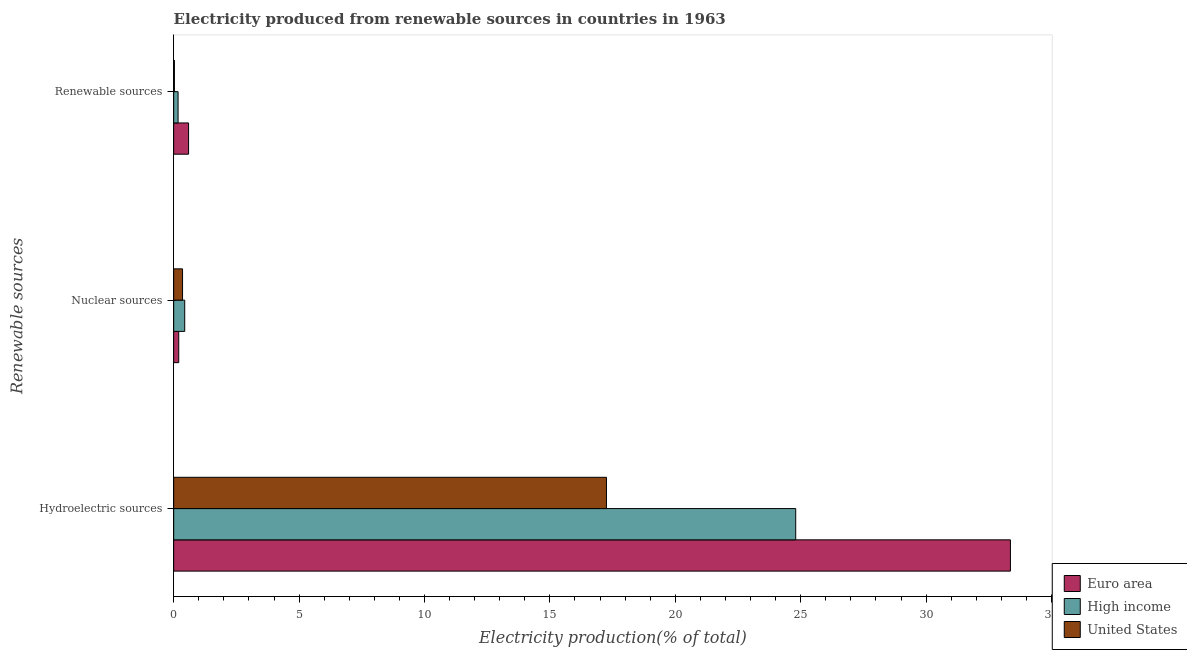Are the number of bars per tick equal to the number of legend labels?
Give a very brief answer. Yes. How many bars are there on the 3rd tick from the top?
Ensure brevity in your answer.  3. How many bars are there on the 2nd tick from the bottom?
Ensure brevity in your answer.  3. What is the label of the 2nd group of bars from the top?
Give a very brief answer. Nuclear sources. What is the percentage of electricity produced by hydroelectric sources in High income?
Keep it short and to the point. 24.8. Across all countries, what is the maximum percentage of electricity produced by renewable sources?
Your answer should be compact. 0.59. Across all countries, what is the minimum percentage of electricity produced by hydroelectric sources?
Ensure brevity in your answer.  17.26. In which country was the percentage of electricity produced by renewable sources maximum?
Keep it short and to the point. Euro area. What is the total percentage of electricity produced by renewable sources in the graph?
Offer a very short reply. 0.8. What is the difference between the percentage of electricity produced by renewable sources in Euro area and that in High income?
Give a very brief answer. 0.42. What is the difference between the percentage of electricity produced by nuclear sources in High income and the percentage of electricity produced by hydroelectric sources in United States?
Give a very brief answer. -16.81. What is the average percentage of electricity produced by hydroelectric sources per country?
Offer a very short reply. 25.14. What is the difference between the percentage of electricity produced by nuclear sources and percentage of electricity produced by hydroelectric sources in High income?
Your response must be concise. -24.36. In how many countries, is the percentage of electricity produced by hydroelectric sources greater than 29 %?
Your answer should be compact. 1. What is the ratio of the percentage of electricity produced by nuclear sources in High income to that in Euro area?
Your answer should be very brief. 2.18. Is the percentage of electricity produced by nuclear sources in United States less than that in Euro area?
Your answer should be very brief. No. Is the difference between the percentage of electricity produced by renewable sources in United States and Euro area greater than the difference between the percentage of electricity produced by hydroelectric sources in United States and Euro area?
Keep it short and to the point. Yes. What is the difference between the highest and the second highest percentage of electricity produced by hydroelectric sources?
Give a very brief answer. 8.56. What is the difference between the highest and the lowest percentage of electricity produced by hydroelectric sources?
Provide a succinct answer. 16.11. In how many countries, is the percentage of electricity produced by renewable sources greater than the average percentage of electricity produced by renewable sources taken over all countries?
Your answer should be very brief. 1. Is the sum of the percentage of electricity produced by hydroelectric sources in United States and Euro area greater than the maximum percentage of electricity produced by nuclear sources across all countries?
Your answer should be compact. Yes. Is it the case that in every country, the sum of the percentage of electricity produced by hydroelectric sources and percentage of electricity produced by nuclear sources is greater than the percentage of electricity produced by renewable sources?
Provide a short and direct response. Yes. How many bars are there?
Offer a very short reply. 9. How many countries are there in the graph?
Give a very brief answer. 3. Are the values on the major ticks of X-axis written in scientific E-notation?
Give a very brief answer. No. Does the graph contain any zero values?
Offer a terse response. No. Does the graph contain grids?
Offer a very short reply. No. How many legend labels are there?
Give a very brief answer. 3. What is the title of the graph?
Your answer should be very brief. Electricity produced from renewable sources in countries in 1963. What is the label or title of the Y-axis?
Offer a terse response. Renewable sources. What is the Electricity production(% of total) in Euro area in Hydroelectric sources?
Keep it short and to the point. 33.36. What is the Electricity production(% of total) of High income in Hydroelectric sources?
Give a very brief answer. 24.8. What is the Electricity production(% of total) in United States in Hydroelectric sources?
Ensure brevity in your answer.  17.26. What is the Electricity production(% of total) of Euro area in Nuclear sources?
Your response must be concise. 0.2. What is the Electricity production(% of total) in High income in Nuclear sources?
Provide a succinct answer. 0.44. What is the Electricity production(% of total) of United States in Nuclear sources?
Give a very brief answer. 0.35. What is the Electricity production(% of total) of Euro area in Renewable sources?
Your response must be concise. 0.59. What is the Electricity production(% of total) of High income in Renewable sources?
Give a very brief answer. 0.18. What is the Electricity production(% of total) in United States in Renewable sources?
Provide a short and direct response. 0.03. Across all Renewable sources, what is the maximum Electricity production(% of total) in Euro area?
Provide a succinct answer. 33.36. Across all Renewable sources, what is the maximum Electricity production(% of total) of High income?
Make the answer very short. 24.8. Across all Renewable sources, what is the maximum Electricity production(% of total) in United States?
Your answer should be very brief. 17.26. Across all Renewable sources, what is the minimum Electricity production(% of total) in Euro area?
Your answer should be compact. 0.2. Across all Renewable sources, what is the minimum Electricity production(% of total) in High income?
Your answer should be very brief. 0.18. Across all Renewable sources, what is the minimum Electricity production(% of total) of United States?
Offer a very short reply. 0.03. What is the total Electricity production(% of total) of Euro area in the graph?
Your answer should be very brief. 34.16. What is the total Electricity production(% of total) of High income in the graph?
Provide a short and direct response. 25.42. What is the total Electricity production(% of total) of United States in the graph?
Offer a terse response. 17.64. What is the difference between the Electricity production(% of total) of Euro area in Hydroelectric sources and that in Nuclear sources?
Offer a very short reply. 33.16. What is the difference between the Electricity production(% of total) in High income in Hydroelectric sources and that in Nuclear sources?
Keep it short and to the point. 24.36. What is the difference between the Electricity production(% of total) of United States in Hydroelectric sources and that in Nuclear sources?
Provide a short and direct response. 16.9. What is the difference between the Electricity production(% of total) in Euro area in Hydroelectric sources and that in Renewable sources?
Provide a succinct answer. 32.77. What is the difference between the Electricity production(% of total) of High income in Hydroelectric sources and that in Renewable sources?
Give a very brief answer. 24.63. What is the difference between the Electricity production(% of total) in United States in Hydroelectric sources and that in Renewable sources?
Keep it short and to the point. 17.23. What is the difference between the Electricity production(% of total) of Euro area in Nuclear sources and that in Renewable sources?
Offer a terse response. -0.39. What is the difference between the Electricity production(% of total) of High income in Nuclear sources and that in Renewable sources?
Offer a terse response. 0.27. What is the difference between the Electricity production(% of total) of United States in Nuclear sources and that in Renewable sources?
Make the answer very short. 0.32. What is the difference between the Electricity production(% of total) of Euro area in Hydroelectric sources and the Electricity production(% of total) of High income in Nuclear sources?
Your answer should be very brief. 32.92. What is the difference between the Electricity production(% of total) in Euro area in Hydroelectric sources and the Electricity production(% of total) in United States in Nuclear sources?
Keep it short and to the point. 33.01. What is the difference between the Electricity production(% of total) in High income in Hydroelectric sources and the Electricity production(% of total) in United States in Nuclear sources?
Provide a succinct answer. 24.45. What is the difference between the Electricity production(% of total) in Euro area in Hydroelectric sources and the Electricity production(% of total) in High income in Renewable sources?
Your answer should be compact. 33.19. What is the difference between the Electricity production(% of total) in Euro area in Hydroelectric sources and the Electricity production(% of total) in United States in Renewable sources?
Provide a short and direct response. 33.33. What is the difference between the Electricity production(% of total) of High income in Hydroelectric sources and the Electricity production(% of total) of United States in Renewable sources?
Provide a succinct answer. 24.77. What is the difference between the Electricity production(% of total) in Euro area in Nuclear sources and the Electricity production(% of total) in High income in Renewable sources?
Give a very brief answer. 0.03. What is the difference between the Electricity production(% of total) of Euro area in Nuclear sources and the Electricity production(% of total) of United States in Renewable sources?
Provide a succinct answer. 0.17. What is the difference between the Electricity production(% of total) in High income in Nuclear sources and the Electricity production(% of total) in United States in Renewable sources?
Ensure brevity in your answer.  0.41. What is the average Electricity production(% of total) in Euro area per Renewable sources?
Provide a succinct answer. 11.39. What is the average Electricity production(% of total) of High income per Renewable sources?
Offer a terse response. 8.47. What is the average Electricity production(% of total) of United States per Renewable sources?
Offer a very short reply. 5.88. What is the difference between the Electricity production(% of total) of Euro area and Electricity production(% of total) of High income in Hydroelectric sources?
Keep it short and to the point. 8.56. What is the difference between the Electricity production(% of total) of Euro area and Electricity production(% of total) of United States in Hydroelectric sources?
Provide a short and direct response. 16.11. What is the difference between the Electricity production(% of total) of High income and Electricity production(% of total) of United States in Hydroelectric sources?
Provide a succinct answer. 7.55. What is the difference between the Electricity production(% of total) in Euro area and Electricity production(% of total) in High income in Nuclear sources?
Your answer should be very brief. -0.24. What is the difference between the Electricity production(% of total) in Euro area and Electricity production(% of total) in United States in Nuclear sources?
Give a very brief answer. -0.15. What is the difference between the Electricity production(% of total) in High income and Electricity production(% of total) in United States in Nuclear sources?
Your answer should be very brief. 0.09. What is the difference between the Electricity production(% of total) in Euro area and Electricity production(% of total) in High income in Renewable sources?
Provide a succinct answer. 0.42. What is the difference between the Electricity production(% of total) in Euro area and Electricity production(% of total) in United States in Renewable sources?
Keep it short and to the point. 0.56. What is the difference between the Electricity production(% of total) of High income and Electricity production(% of total) of United States in Renewable sources?
Ensure brevity in your answer.  0.15. What is the ratio of the Electricity production(% of total) of Euro area in Hydroelectric sources to that in Nuclear sources?
Ensure brevity in your answer.  165.41. What is the ratio of the Electricity production(% of total) in High income in Hydroelectric sources to that in Nuclear sources?
Keep it short and to the point. 56.29. What is the ratio of the Electricity production(% of total) of United States in Hydroelectric sources to that in Nuclear sources?
Your response must be concise. 48.78. What is the ratio of the Electricity production(% of total) of Euro area in Hydroelectric sources to that in Renewable sources?
Your response must be concise. 56.14. What is the ratio of the Electricity production(% of total) in High income in Hydroelectric sources to that in Renewable sources?
Give a very brief answer. 141.25. What is the ratio of the Electricity production(% of total) in United States in Hydroelectric sources to that in Renewable sources?
Provide a succinct answer. 586.22. What is the ratio of the Electricity production(% of total) in Euro area in Nuclear sources to that in Renewable sources?
Offer a very short reply. 0.34. What is the ratio of the Electricity production(% of total) of High income in Nuclear sources to that in Renewable sources?
Give a very brief answer. 2.51. What is the ratio of the Electricity production(% of total) in United States in Nuclear sources to that in Renewable sources?
Ensure brevity in your answer.  12.02. What is the difference between the highest and the second highest Electricity production(% of total) of Euro area?
Ensure brevity in your answer.  32.77. What is the difference between the highest and the second highest Electricity production(% of total) in High income?
Your answer should be compact. 24.36. What is the difference between the highest and the second highest Electricity production(% of total) in United States?
Keep it short and to the point. 16.9. What is the difference between the highest and the lowest Electricity production(% of total) in Euro area?
Offer a very short reply. 33.16. What is the difference between the highest and the lowest Electricity production(% of total) in High income?
Give a very brief answer. 24.63. What is the difference between the highest and the lowest Electricity production(% of total) in United States?
Your answer should be compact. 17.23. 